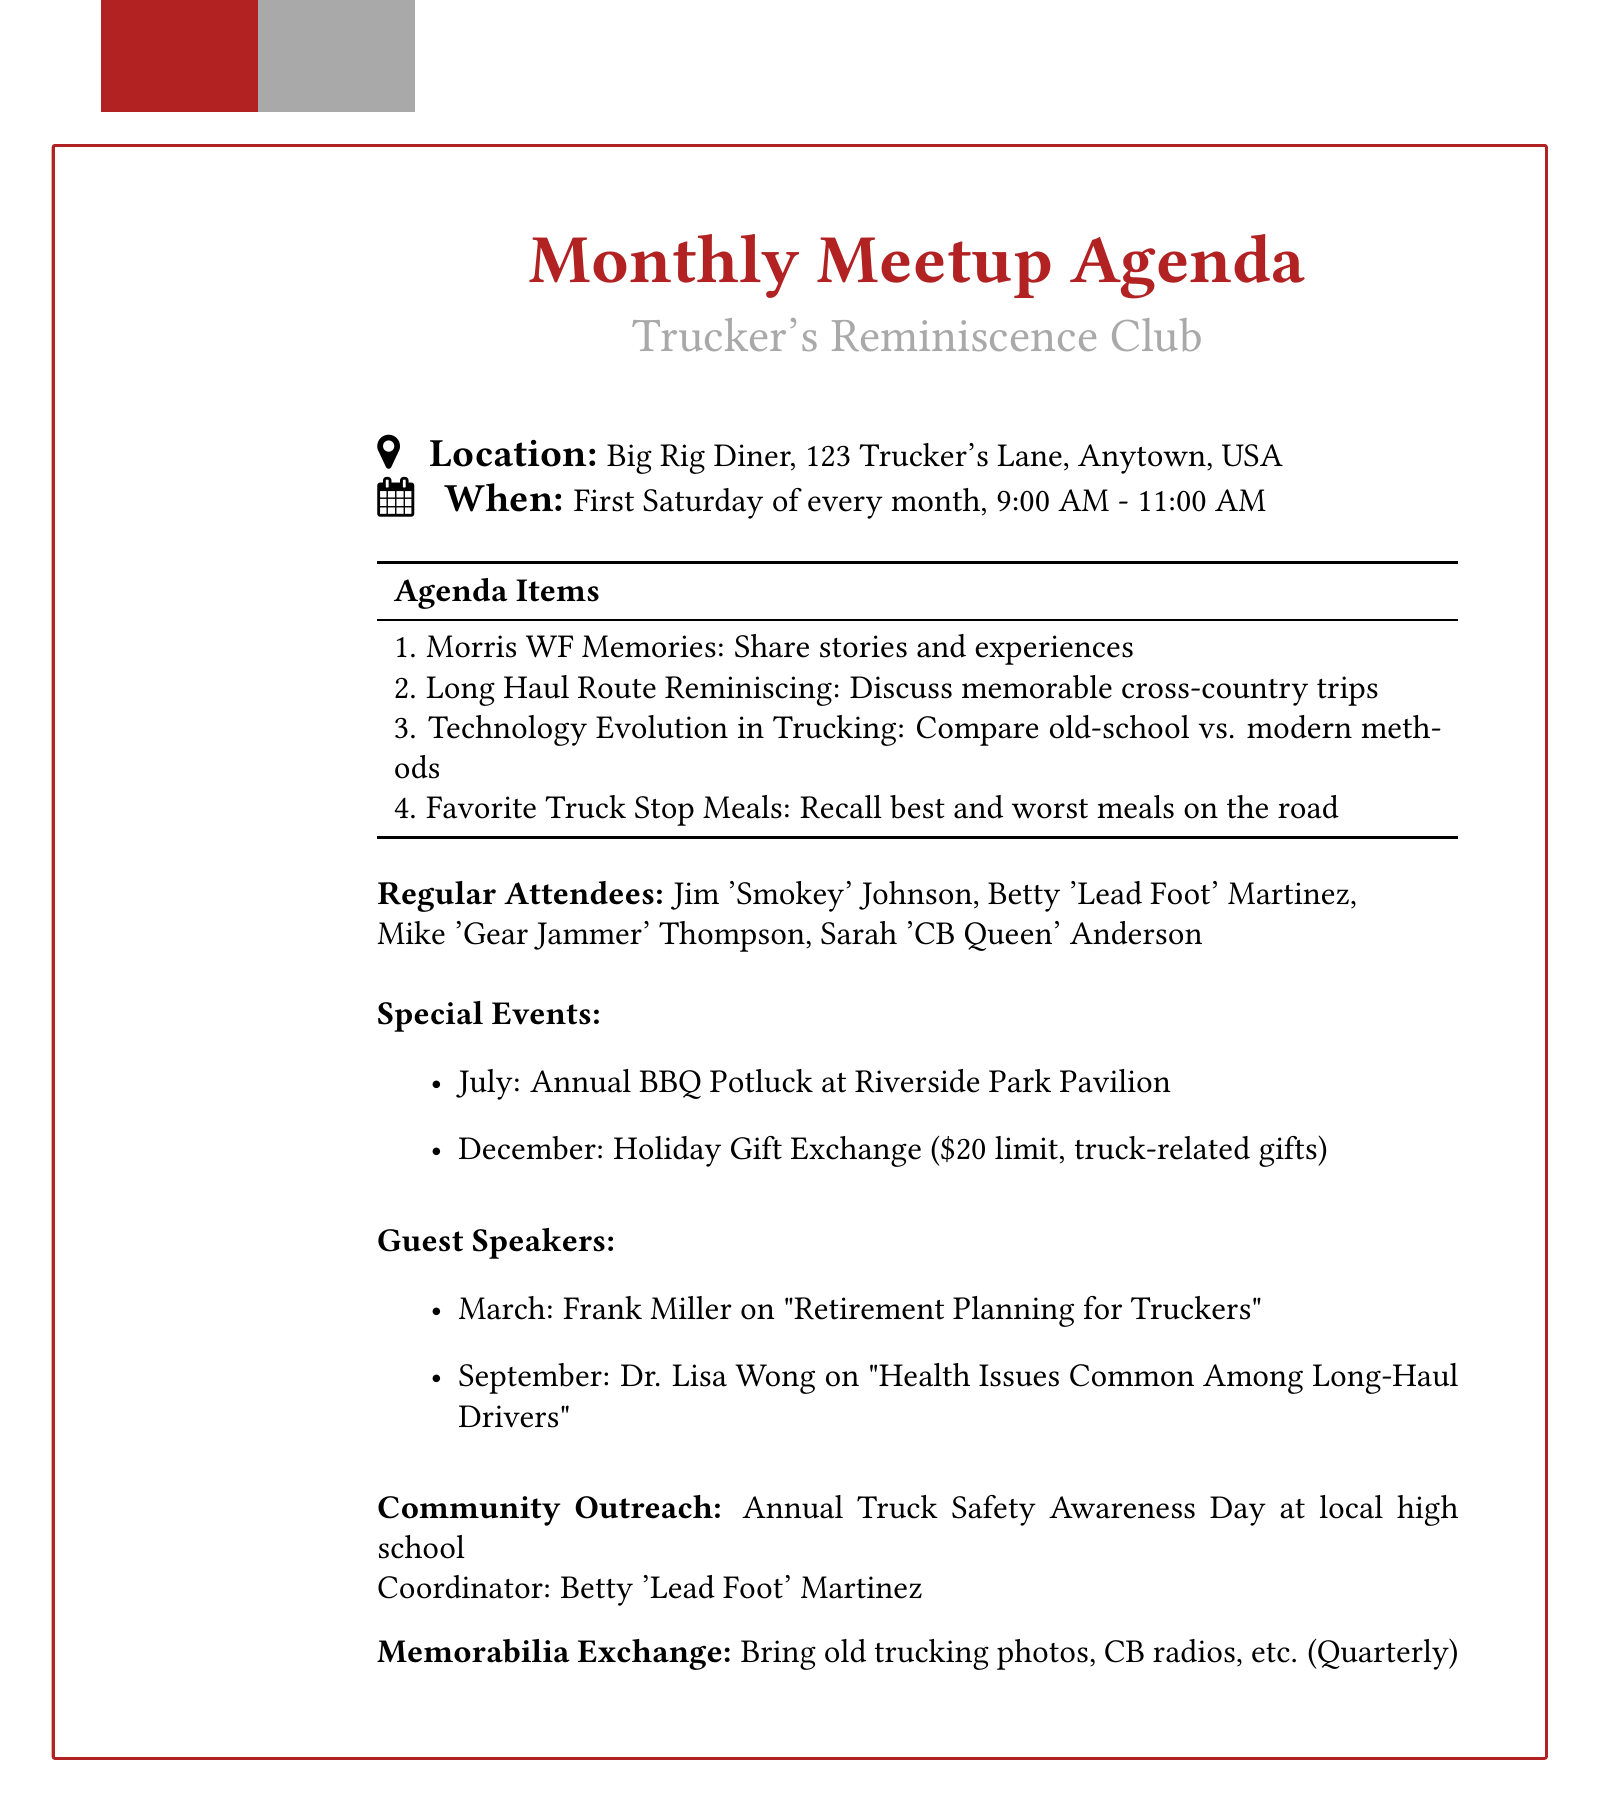What is the location of the monthly meetups? The location is provided clearly in the document as Big Rig Diner, including its address.
Answer: Big Rig Diner, 123 Trucker's Lane, Anytown, USA When is the monthly meeting scheduled? The frequency and specific day of the meetups are stated, along with the time.
Answer: First Saturday of every month Who are the regular attendees? The document lists four regular attendees by name and nickname.
Answer: Jim 'Smokey' Johnson, Betty 'Lead Foot' Martinez, Mike 'Gear Jammer' Thompson, Sarah 'CB Queen' Anderson What is one of the agenda items? The agenda includes various items, and one specific item is easily retrievable from the list.
Answer: Morris WF Memories What is the tentative date for Frank Miller's guest speaking? The document specifies a month for Frank Miller’s talk on retirement planning.
Answer: March meeting What special event is scheduled for December? The document mentions a special event planned for December along with its details.
Answer: Holiday Gift Exchange What activity does the community outreach involve? The document outlines a specific activity associated with community outreach efforts.
Answer: Truck Safety Awareness Day How often is the memorabilia exchange? The document indicates the frequency of this particular exchange activity.
Answer: Quarterly 